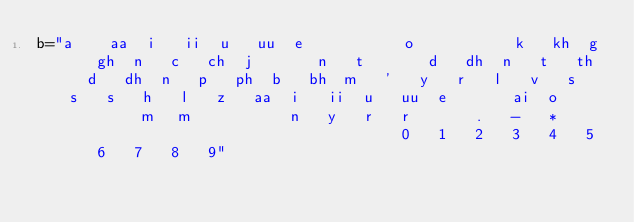<code> <loc_0><loc_0><loc_500><loc_500><_Python_>b="a	aa	i	ii	u	uu	e			o			k	kh	g	gh	n	c	ch	j		n	t		d	dh	n	t	th	d	dh	n	p	ph	b	bh	m	'	y	r	l	v	s	s	s	h	l	z	aa	i	ii	u	uu	e		ai	o			m	m			n	y	r	r		.	-	*										0	1	2	3	4	5	6	7	8	9"</code> 